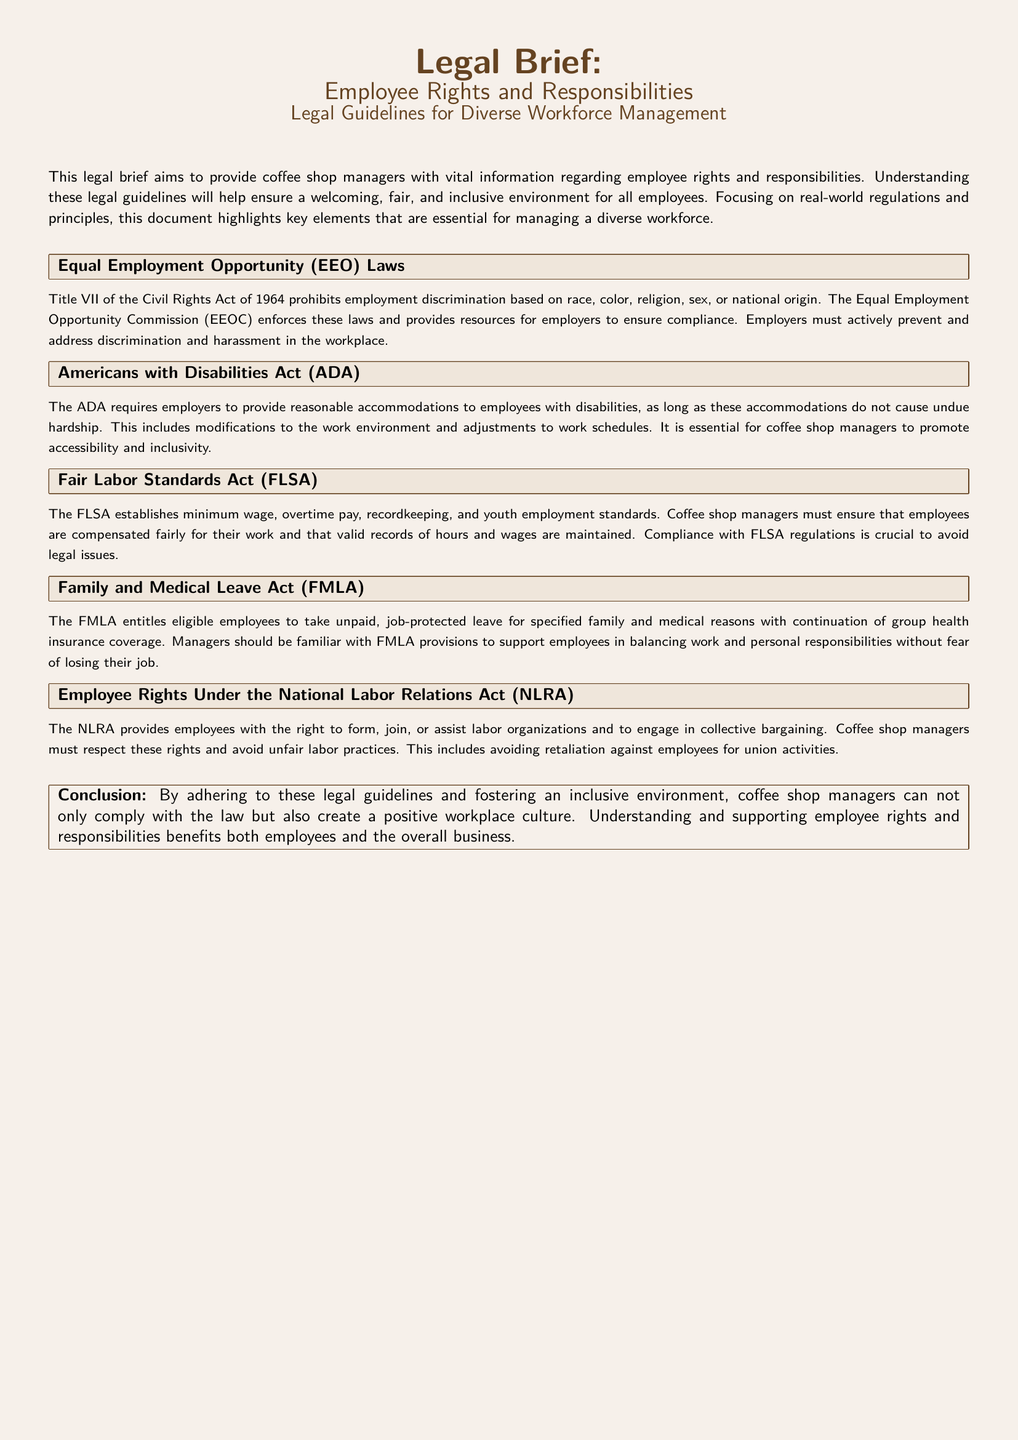What law prohibits employment discrimination? The document mentions Title VII of the Civil Rights Act of 1964 as the law that prohibits discrimination.
Answer: Title VII of the Civil Rights Act of 1964 What does the ADA require from employers? The ADA requires employers to provide reasonable accommodations for employees with disabilities.
Answer: Reasonable accommodations What must coffee shop managers ensure according to the FLSA? The FLSA emphasizes that employees must be compensated fairly for their work and valid records must be maintained.
Answer: Fair compensation and recordkeeping What type of leave does the FMLA provide? The FMLA entitles employees to unpaid, job-protected leave for family and medical reasons.
Answer: Unpaid, job-protected leave What rights does the NLRA grant to employees? The NLRA grants employees the right to form, join, or assist labor organizations and engage in collective bargaining.
Answer: Right to organize and bargain What helps create a positive workplace culture according to the conclusion? The conclusion states that adhering to legal guidelines and fostering an inclusive environment helps create a positive workplace culture.
Answer: Fostering an inclusive environment How should managers treat employees engaging in union activities? The document states that managers must respect employees' rights and avoid retaliation for union activities.
Answer: Avoid retaliation In which section is the Americans with Disabilities Act discussed? The section detailing the ADA can be found under its titled section in the document.
Answer: ADA section 